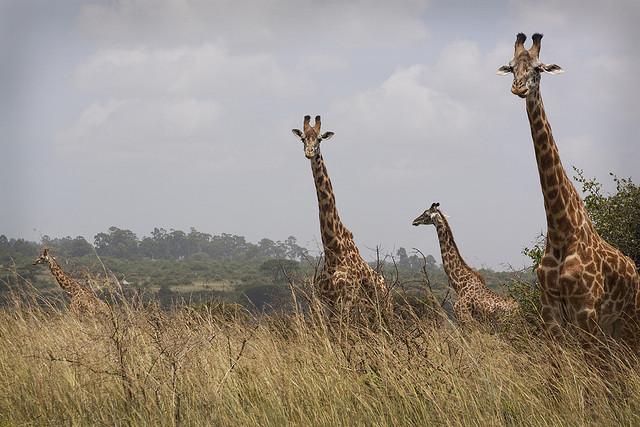How many giraffes are there?
Be succinct. 4. Do the animals look interested in the photographer?
Answer briefly. Yes. What is on the left of the animals?
Answer briefly. Grass. Can you see these animals in a zoo?
Concise answer only. Yes. Is the wind blowing?
Keep it brief. Yes. How many zebras are there?
Quick response, please. 0. 